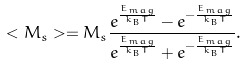Convert formula to latex. <formula><loc_0><loc_0><loc_500><loc_500>< M _ { s } > = M _ { s } \frac { e ^ { \frac { E _ { m a g } } { k _ { B } T } } - e ^ { - { \frac { E _ { m a g } } { k _ { B } T } } } } { e ^ { \frac { E _ { m a g } } { k _ { B } T } } + e ^ { - { \frac { E _ { m a g } } { k _ { B } T } } } } .</formula> 